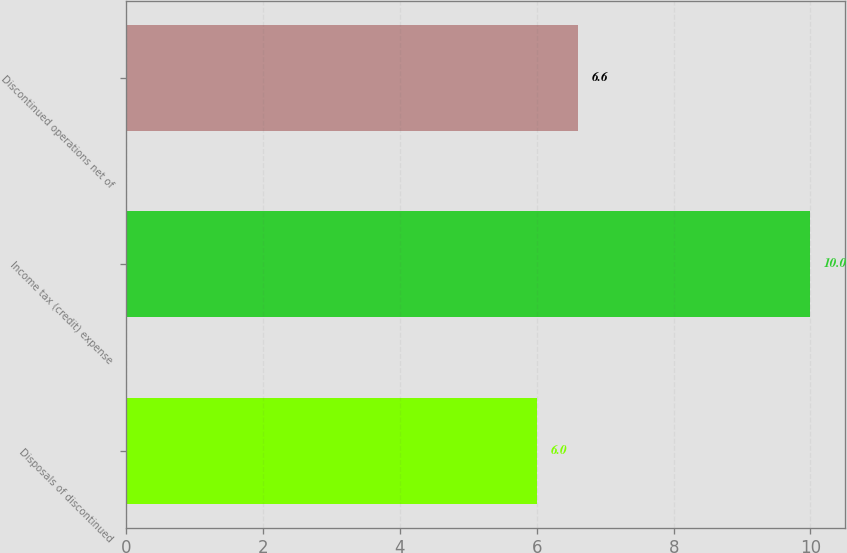<chart> <loc_0><loc_0><loc_500><loc_500><bar_chart><fcel>Disposals of discontinued<fcel>Income tax (credit) expense<fcel>Discontinued operations net of<nl><fcel>6<fcel>10<fcel>6.6<nl></chart> 